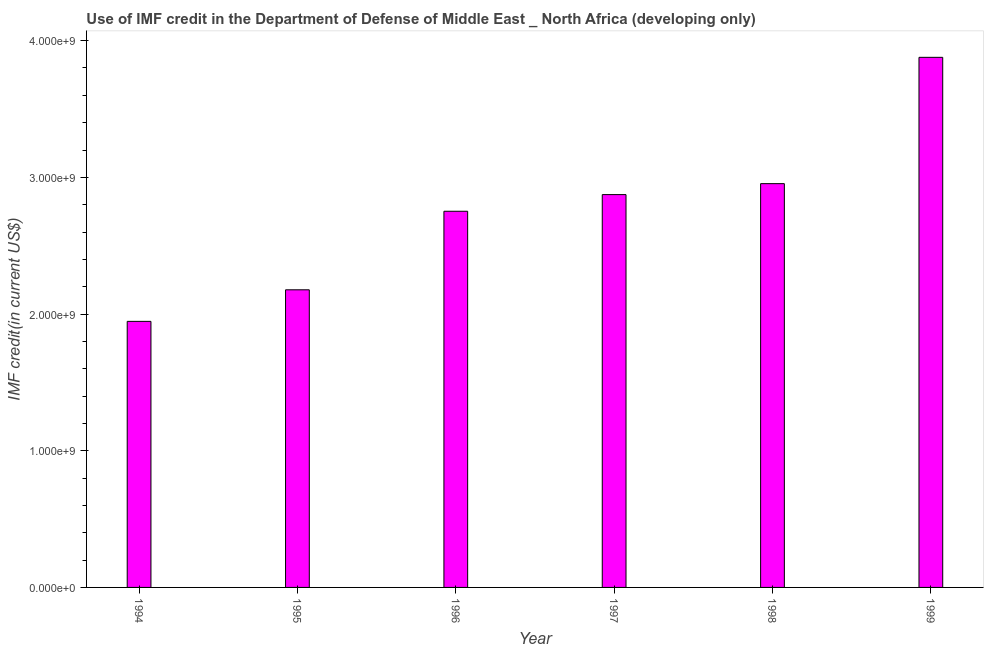What is the title of the graph?
Offer a terse response. Use of IMF credit in the Department of Defense of Middle East _ North Africa (developing only). What is the label or title of the X-axis?
Make the answer very short. Year. What is the label or title of the Y-axis?
Offer a terse response. IMF credit(in current US$). What is the use of imf credit in dod in 1998?
Your answer should be compact. 2.95e+09. Across all years, what is the maximum use of imf credit in dod?
Your response must be concise. 3.88e+09. Across all years, what is the minimum use of imf credit in dod?
Give a very brief answer. 1.95e+09. In which year was the use of imf credit in dod maximum?
Make the answer very short. 1999. What is the sum of the use of imf credit in dod?
Give a very brief answer. 1.66e+1. What is the difference between the use of imf credit in dod in 1994 and 1998?
Ensure brevity in your answer.  -1.01e+09. What is the average use of imf credit in dod per year?
Give a very brief answer. 2.76e+09. What is the median use of imf credit in dod?
Your response must be concise. 2.81e+09. Do a majority of the years between 1994 and 1996 (inclusive) have use of imf credit in dod greater than 3800000000 US$?
Provide a short and direct response. No. What is the ratio of the use of imf credit in dod in 1997 to that in 1999?
Give a very brief answer. 0.74. Is the difference between the use of imf credit in dod in 1995 and 1996 greater than the difference between any two years?
Provide a short and direct response. No. What is the difference between the highest and the second highest use of imf credit in dod?
Make the answer very short. 9.24e+08. Is the sum of the use of imf credit in dod in 1994 and 1995 greater than the maximum use of imf credit in dod across all years?
Your answer should be compact. Yes. What is the difference between the highest and the lowest use of imf credit in dod?
Your response must be concise. 1.93e+09. How many bars are there?
Your answer should be compact. 6. Are all the bars in the graph horizontal?
Ensure brevity in your answer.  No. Are the values on the major ticks of Y-axis written in scientific E-notation?
Offer a terse response. Yes. What is the IMF credit(in current US$) of 1994?
Give a very brief answer. 1.95e+09. What is the IMF credit(in current US$) in 1995?
Your response must be concise. 2.18e+09. What is the IMF credit(in current US$) in 1996?
Offer a very short reply. 2.75e+09. What is the IMF credit(in current US$) in 1997?
Your answer should be compact. 2.87e+09. What is the IMF credit(in current US$) of 1998?
Keep it short and to the point. 2.95e+09. What is the IMF credit(in current US$) in 1999?
Offer a terse response. 3.88e+09. What is the difference between the IMF credit(in current US$) in 1994 and 1995?
Offer a very short reply. -2.31e+08. What is the difference between the IMF credit(in current US$) in 1994 and 1996?
Keep it short and to the point. -8.06e+08. What is the difference between the IMF credit(in current US$) in 1994 and 1997?
Give a very brief answer. -9.27e+08. What is the difference between the IMF credit(in current US$) in 1994 and 1998?
Your answer should be very brief. -1.01e+09. What is the difference between the IMF credit(in current US$) in 1994 and 1999?
Offer a terse response. -1.93e+09. What is the difference between the IMF credit(in current US$) in 1995 and 1996?
Provide a succinct answer. -5.75e+08. What is the difference between the IMF credit(in current US$) in 1995 and 1997?
Make the answer very short. -6.96e+08. What is the difference between the IMF credit(in current US$) in 1995 and 1998?
Keep it short and to the point. -7.77e+08. What is the difference between the IMF credit(in current US$) in 1995 and 1999?
Make the answer very short. -1.70e+09. What is the difference between the IMF credit(in current US$) in 1996 and 1997?
Offer a very short reply. -1.22e+08. What is the difference between the IMF credit(in current US$) in 1996 and 1998?
Ensure brevity in your answer.  -2.02e+08. What is the difference between the IMF credit(in current US$) in 1996 and 1999?
Your answer should be compact. -1.13e+09. What is the difference between the IMF credit(in current US$) in 1997 and 1998?
Keep it short and to the point. -8.02e+07. What is the difference between the IMF credit(in current US$) in 1997 and 1999?
Your response must be concise. -1.00e+09. What is the difference between the IMF credit(in current US$) in 1998 and 1999?
Provide a succinct answer. -9.24e+08. What is the ratio of the IMF credit(in current US$) in 1994 to that in 1995?
Your answer should be very brief. 0.89. What is the ratio of the IMF credit(in current US$) in 1994 to that in 1996?
Give a very brief answer. 0.71. What is the ratio of the IMF credit(in current US$) in 1994 to that in 1997?
Offer a very short reply. 0.68. What is the ratio of the IMF credit(in current US$) in 1994 to that in 1998?
Your response must be concise. 0.66. What is the ratio of the IMF credit(in current US$) in 1994 to that in 1999?
Your answer should be compact. 0.5. What is the ratio of the IMF credit(in current US$) in 1995 to that in 1996?
Offer a very short reply. 0.79. What is the ratio of the IMF credit(in current US$) in 1995 to that in 1997?
Keep it short and to the point. 0.76. What is the ratio of the IMF credit(in current US$) in 1995 to that in 1998?
Your answer should be compact. 0.74. What is the ratio of the IMF credit(in current US$) in 1995 to that in 1999?
Give a very brief answer. 0.56. What is the ratio of the IMF credit(in current US$) in 1996 to that in 1997?
Your response must be concise. 0.96. What is the ratio of the IMF credit(in current US$) in 1996 to that in 1998?
Your answer should be compact. 0.93. What is the ratio of the IMF credit(in current US$) in 1996 to that in 1999?
Give a very brief answer. 0.71. What is the ratio of the IMF credit(in current US$) in 1997 to that in 1999?
Your answer should be very brief. 0.74. What is the ratio of the IMF credit(in current US$) in 1998 to that in 1999?
Provide a short and direct response. 0.76. 